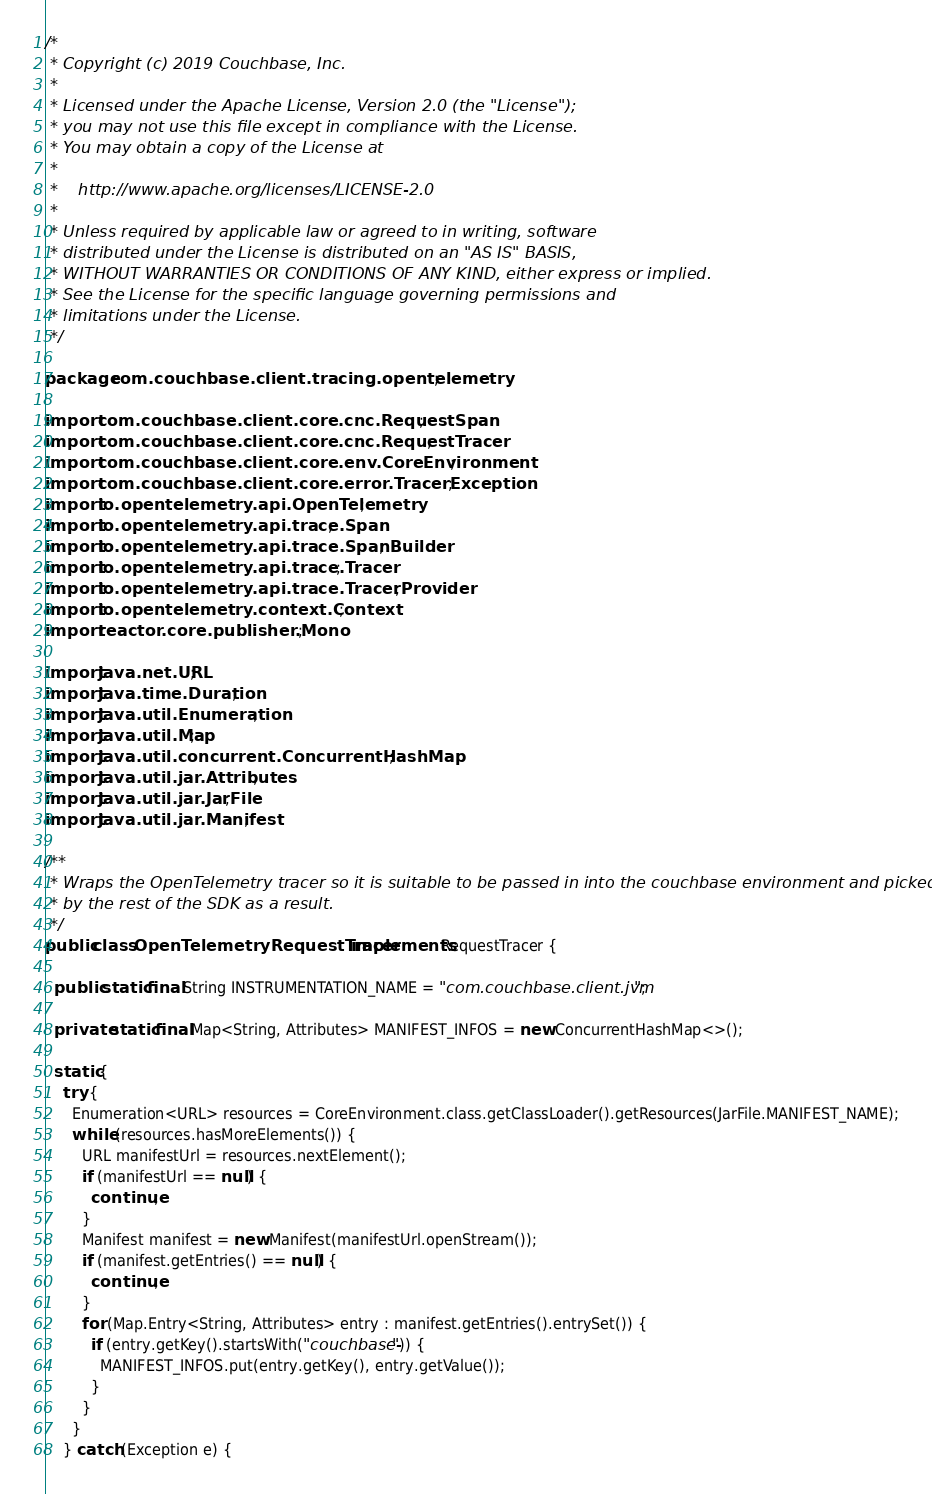<code> <loc_0><loc_0><loc_500><loc_500><_Java_>/*
 * Copyright (c) 2019 Couchbase, Inc.
 *
 * Licensed under the Apache License, Version 2.0 (the "License");
 * you may not use this file except in compliance with the License.
 * You may obtain a copy of the License at
 *
 *    http://www.apache.org/licenses/LICENSE-2.0
 *
 * Unless required by applicable law or agreed to in writing, software
 * distributed under the License is distributed on an "AS IS" BASIS,
 * WITHOUT WARRANTIES OR CONDITIONS OF ANY KIND, either express or implied.
 * See the License for the specific language governing permissions and
 * limitations under the License.
 */

package com.couchbase.client.tracing.opentelemetry;

import com.couchbase.client.core.cnc.RequestSpan;
import com.couchbase.client.core.cnc.RequestTracer;
import com.couchbase.client.core.env.CoreEnvironment;
import com.couchbase.client.core.error.TracerException;
import io.opentelemetry.api.OpenTelemetry;
import io.opentelemetry.api.trace.Span;
import io.opentelemetry.api.trace.SpanBuilder;
import io.opentelemetry.api.trace.Tracer;
import io.opentelemetry.api.trace.TracerProvider;
import io.opentelemetry.context.Context;
import reactor.core.publisher.Mono;

import java.net.URL;
import java.time.Duration;
import java.util.Enumeration;
import java.util.Map;
import java.util.concurrent.ConcurrentHashMap;
import java.util.jar.Attributes;
import java.util.jar.JarFile;
import java.util.jar.Manifest;

/**
 * Wraps the OpenTelemetry tracer so it is suitable to be passed in into the couchbase environment and picked up
 * by the rest of the SDK as a result.
 */
public class OpenTelemetryRequestTracer implements RequestTracer {

  public static final String INSTRUMENTATION_NAME = "com.couchbase.client.jvm";

  private static final Map<String, Attributes> MANIFEST_INFOS = new ConcurrentHashMap<>();

  static {
    try {
      Enumeration<URL> resources = CoreEnvironment.class.getClassLoader().getResources(JarFile.MANIFEST_NAME);
      while (resources.hasMoreElements()) {
        URL manifestUrl = resources.nextElement();
        if (manifestUrl == null) {
          continue;
        }
        Manifest manifest = new Manifest(manifestUrl.openStream());
        if (manifest.getEntries() == null) {
          continue;
        }
        for (Map.Entry<String, Attributes> entry : manifest.getEntries().entrySet()) {
          if (entry.getKey().startsWith("couchbase-")) {
            MANIFEST_INFOS.put(entry.getKey(), entry.getValue());
          }
        }
      }
    } catch (Exception e) {</code> 